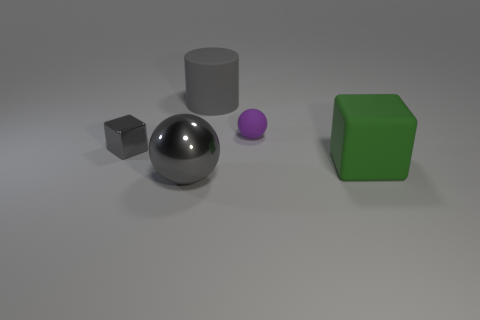There is a gray thing that is the same shape as the purple rubber object; what size is it?
Your answer should be very brief. Large. What is the ball that is right of the ball in front of the small purple sphere that is behind the gray cube made of?
Your answer should be very brief. Rubber. Is the number of big metal things in front of the green rubber cube greater than the number of small metallic objects behind the tiny purple ball?
Your answer should be very brief. Yes. Is the size of the rubber sphere the same as the green rubber cube?
Your response must be concise. No. There is another thing that is the same shape as the purple thing; what is its color?
Your answer should be very brief. Gray. What number of tiny blocks are the same color as the large cylinder?
Keep it short and to the point. 1. Is the number of large things behind the tiny block greater than the number of yellow matte balls?
Make the answer very short. Yes. The matte object that is to the left of the sphere on the right side of the gray rubber thing is what color?
Offer a terse response. Gray. How many objects are either gray shiny things left of the large metallic ball or small things right of the small block?
Your answer should be compact. 2. The large rubber cylinder is what color?
Offer a very short reply. Gray. 